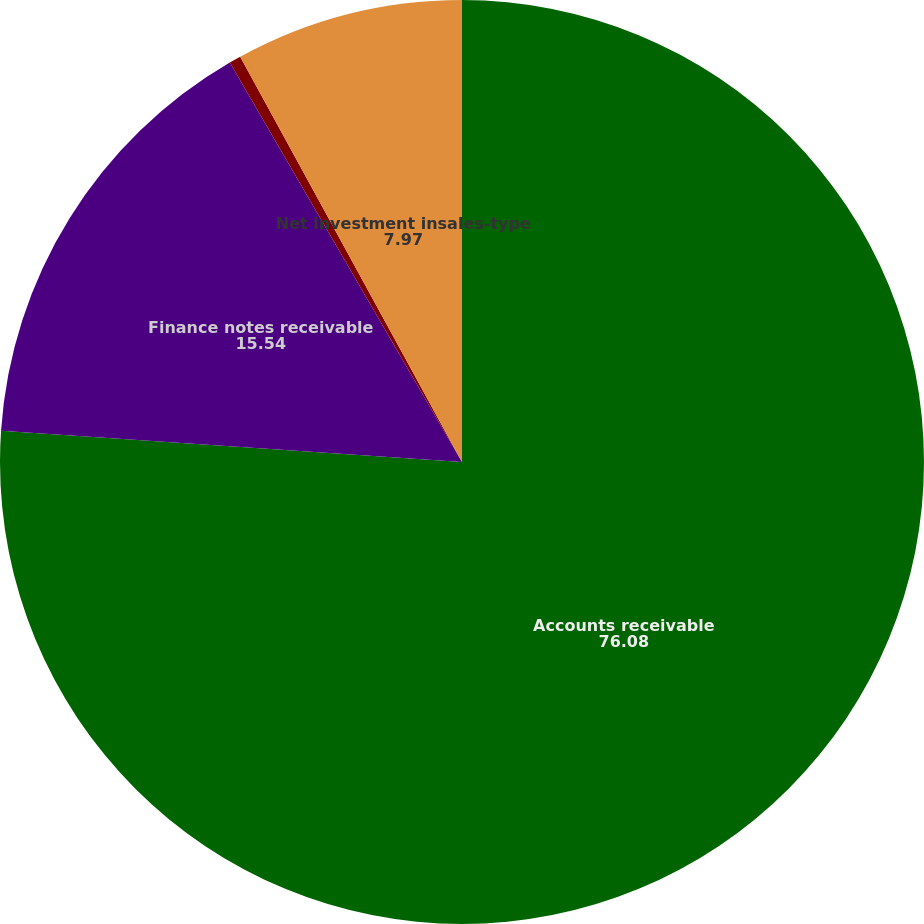<chart> <loc_0><loc_0><loc_500><loc_500><pie_chart><fcel>Accounts receivable<fcel>Finance notes receivable<fcel>Net investment in sales-type<fcel>Net investment insales-type<nl><fcel>76.08%<fcel>15.54%<fcel>0.41%<fcel>7.97%<nl></chart> 